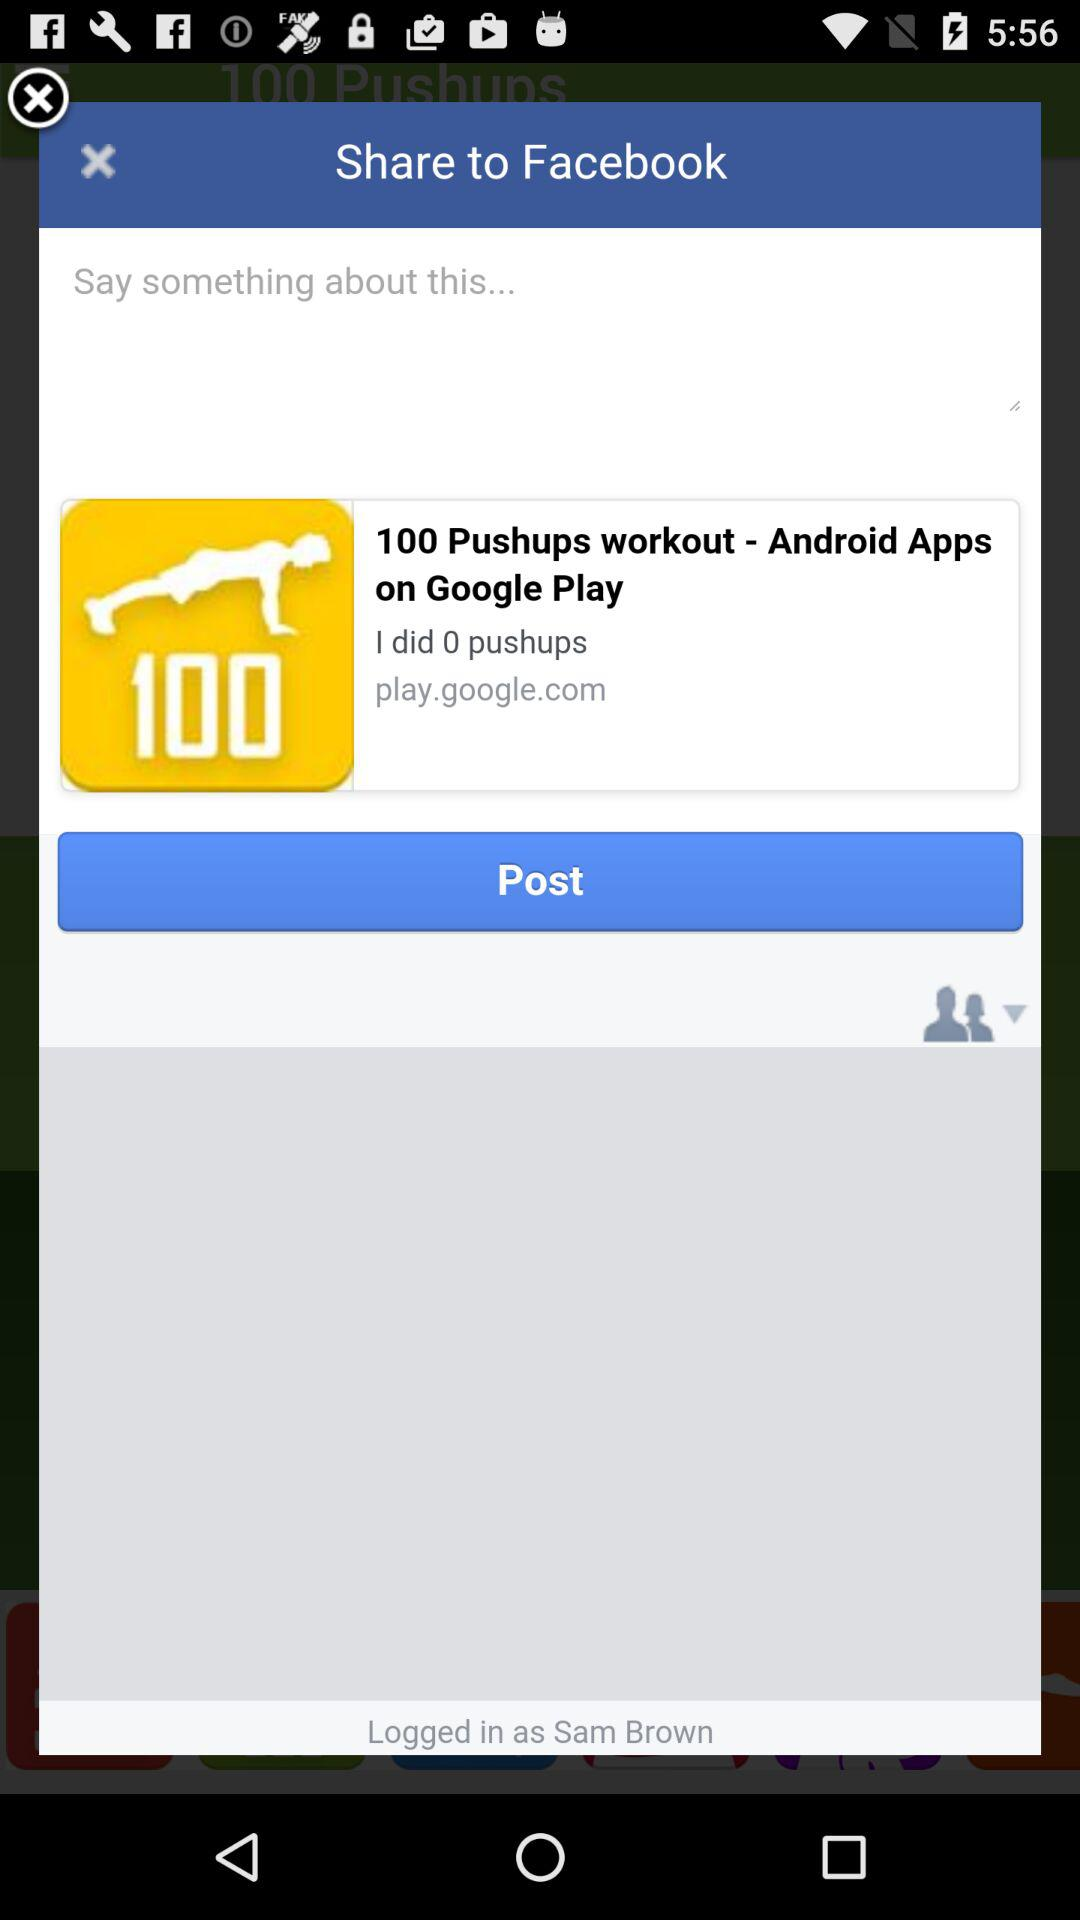What is the name of the user? The name of the user is Sam Brown. 